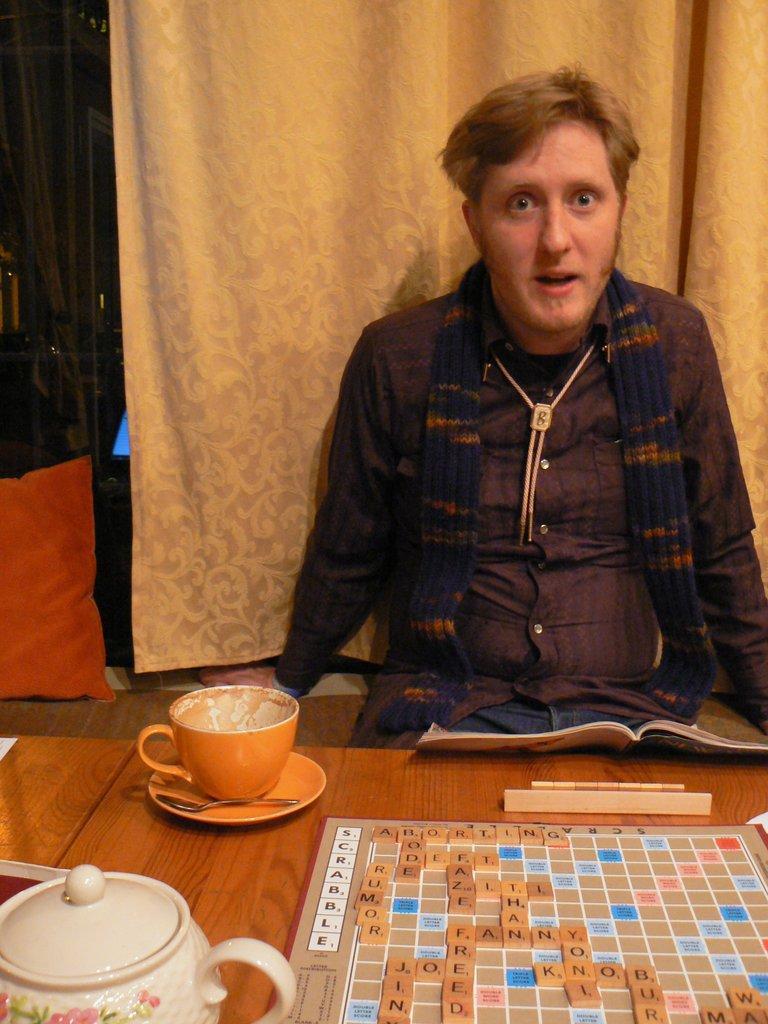Please provide a concise description of this image. In the image we can see a man wearing clothes, he is sitting. There is a book, tea cup, saucer, spoon and tea pot. There is a board, curtains, pillow and a floor, this is a wooden surface. 